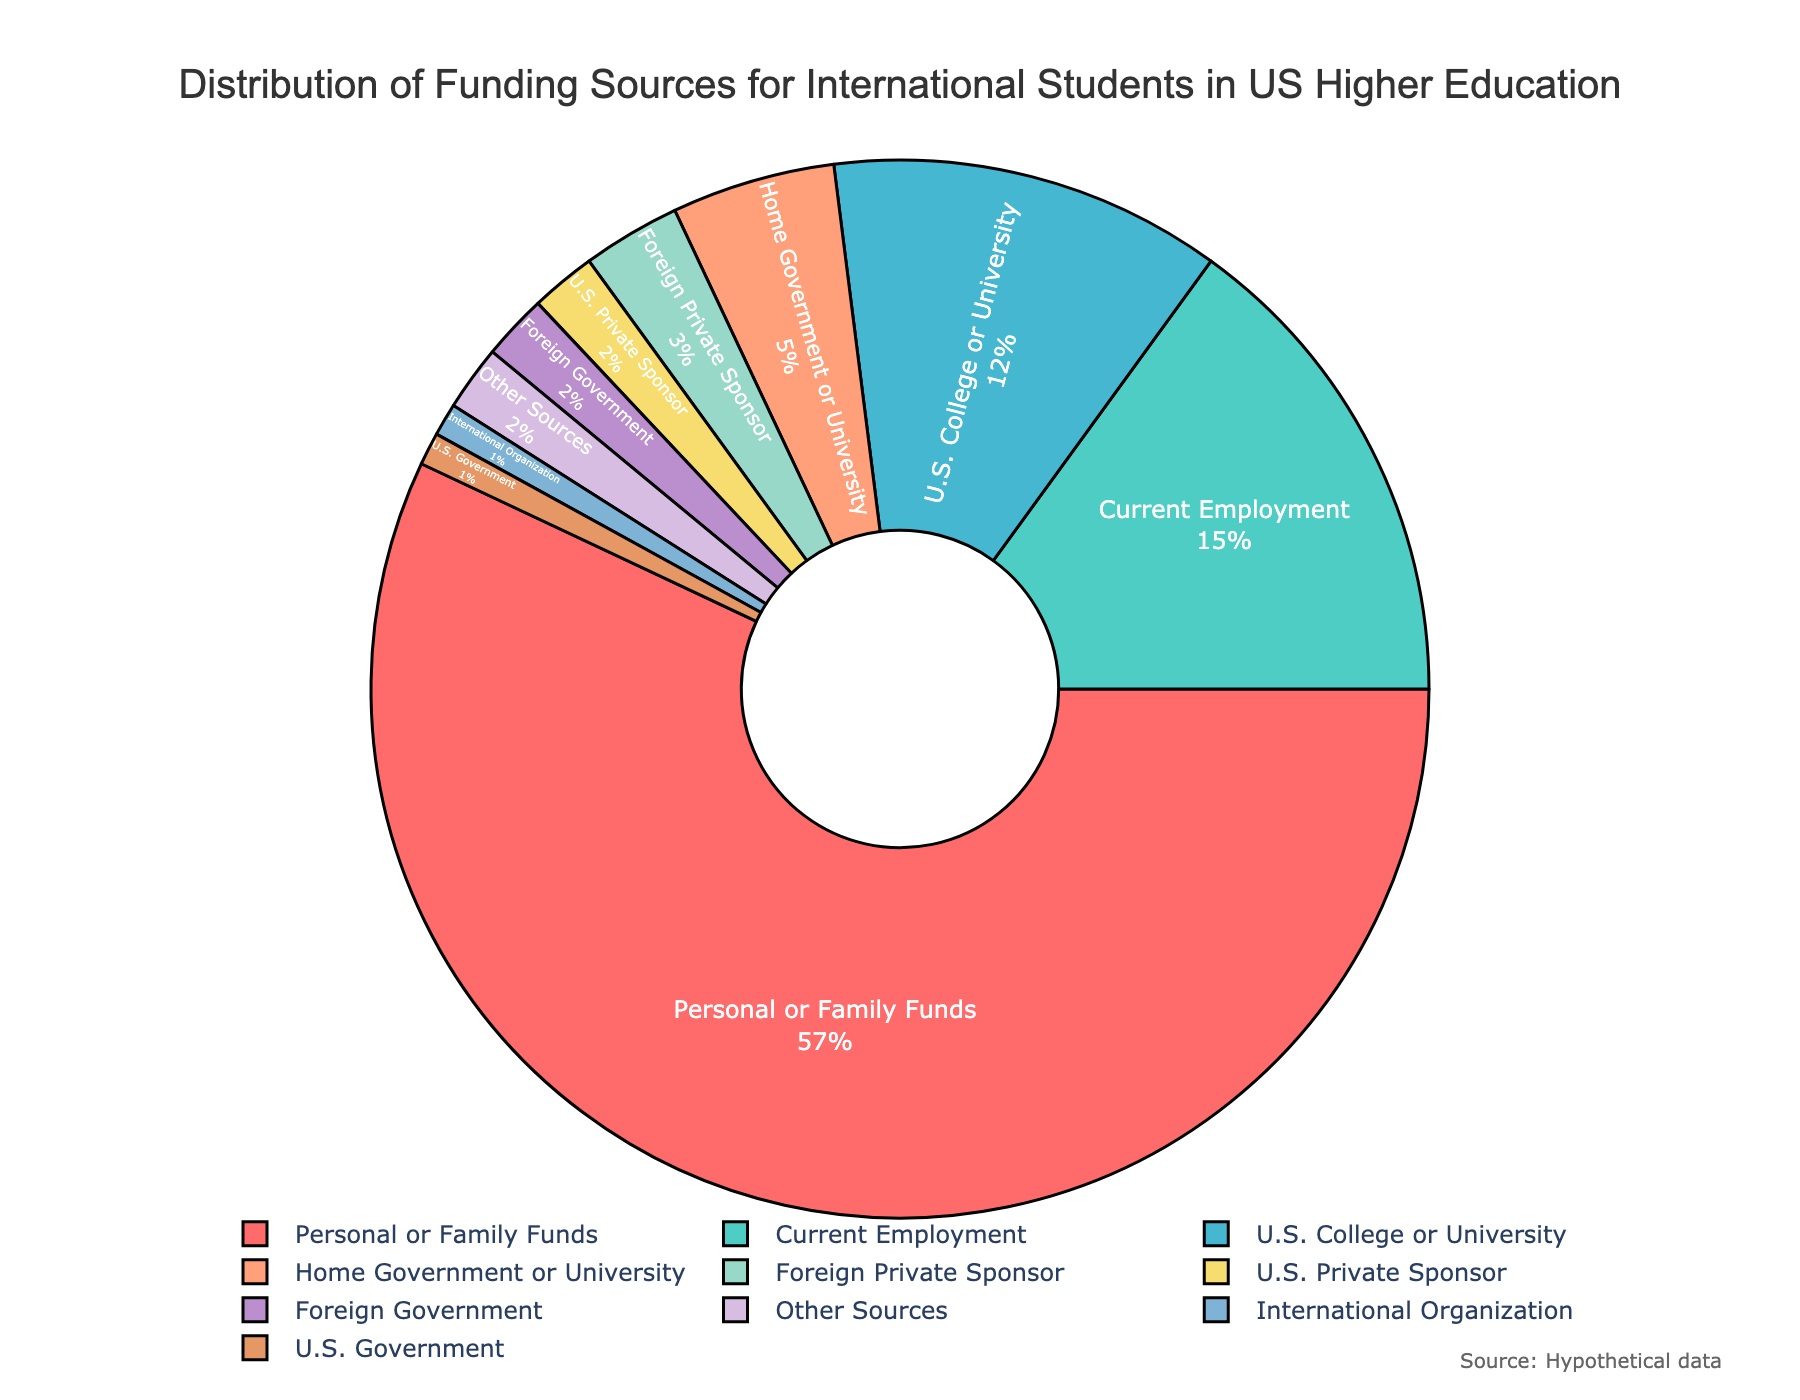What's the funding source with the highest percentage? The segment labeled 'Personal or Family Funds' appears the largest. According to the tooltip or label on the figure, it accounts for 57%.
Answer: Personal or Family Funds What's the total percentage of funding from U.S.-based sources? Add the percentages of 'Current Employment' (15%), 'U.S. College or University' (12%), 'U.S. Private Sponsor' (2%), and 'U.S. Government' (1%). Therefore, the total is 15 + 12 + 2 + 1 = 30%.
Answer: 30% How does the percentage of funding from 'Foreign Government' compare to 'U.S. Private Sponsor'? Compare the segments labeled 'Foreign Government' (2%) and 'U.S. Private Sponsor' (2%). Both have equal percentages.
Answer: They are equal Which funding sources contribute the least to the total percentage? The smallest segments are labeled 'Foreign Private Sponsor', 'U.S. Private Sponsor', 'Foreign Government', 'International Organization', and 'Other Sources', each with 2% or less. 'Foreign Private Sponsor' and 'International Organization' are the least with 1% each.
Answer: International Organization How much more percentage do 'Personal or Family Funds' contribute compared to 'U.S. College or University'? Subtract the percentage of 'U.S. College or University' (12%) from 'Personal or Family Funds' (57%). 57 - 12 = 45%.
Answer: 45% What's the combined percentage of sources contributing less than 10% each? Sum the percentages of 'Home Government or University' (5%), 'Foreign Private Sponsor' (3%), 'U.S. Private Sponsor' (2%), 'Foreign Government' (2%), 'International Organization' (1%), and 'Other Sources' (2%). So, 5 + 3 + 2 + 2 + 1 + 2 = 15%.
Answer: 15% What color is used for the 'Current Employment' segment? By visually inspecting the chart, the 'Current Employment' segment is represented in green. This can typically be verified by the plot's color legend or the distinct color code.
Answer: Green How much smaller is the funding percentage from 'Home Government or University' compared to 'Current Employment'? Subtract the percentage of 'Home Government or University' (5%) from 'Current Employment' (15%). 15 - 5 = 10%.
Answer: 10% What is the average percentage of funding sources excluding 'Personal or Family Funds'? Calculate the total percentage of all other sources (100 - 57 = 43%) and then divide by the number of other sources (9). So, 43 / 9 ≈ 4.78%.
Answer: Approximately 4.78% Which funding source is represented by a red color? By observing the chart visually, the 'Personal or Family Funds' segment is depicted in red, which is the largest segment.
Answer: Personal or Family Funds 